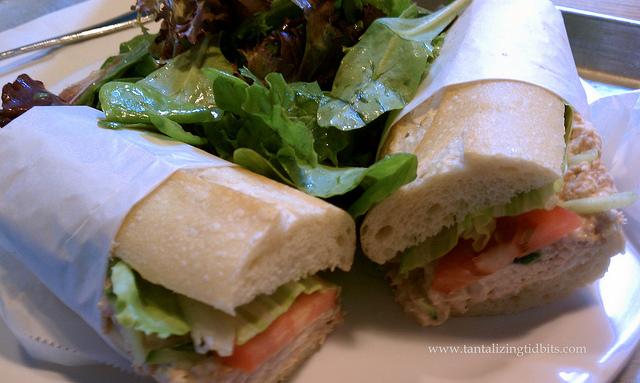How many sandwich on are on the plate?
Concise answer only. 2. Is the sandwich on a cutting board?
Give a very brief answer. No. What kind of bread is on the sandwich?
Quick response, please. White. What is the sandwich wrapped in?
Quick response, please. Paper. 